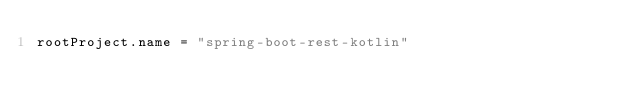<code> <loc_0><loc_0><loc_500><loc_500><_Kotlin_>rootProject.name = "spring-boot-rest-kotlin"
</code> 